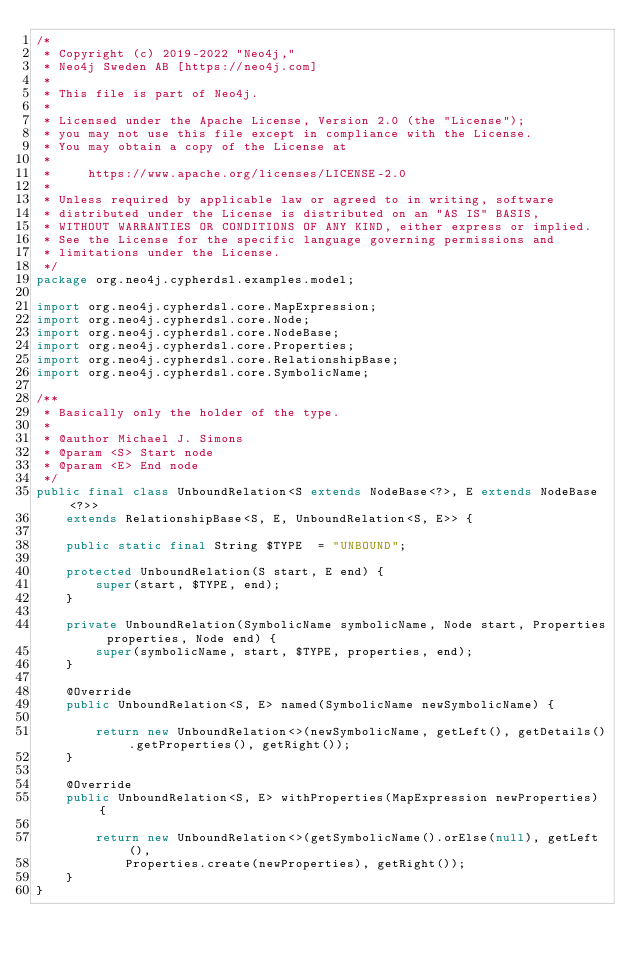Convert code to text. <code><loc_0><loc_0><loc_500><loc_500><_Java_>/*
 * Copyright (c) 2019-2022 "Neo4j,"
 * Neo4j Sweden AB [https://neo4j.com]
 *
 * This file is part of Neo4j.
 *
 * Licensed under the Apache License, Version 2.0 (the "License");
 * you may not use this file except in compliance with the License.
 * You may obtain a copy of the License at
 *
 *     https://www.apache.org/licenses/LICENSE-2.0
 *
 * Unless required by applicable law or agreed to in writing, software
 * distributed under the License is distributed on an "AS IS" BASIS,
 * WITHOUT WARRANTIES OR CONDITIONS OF ANY KIND, either express or implied.
 * See the License for the specific language governing permissions and
 * limitations under the License.
 */
package org.neo4j.cypherdsl.examples.model;

import org.neo4j.cypherdsl.core.MapExpression;
import org.neo4j.cypherdsl.core.Node;
import org.neo4j.cypherdsl.core.NodeBase;
import org.neo4j.cypherdsl.core.Properties;
import org.neo4j.cypherdsl.core.RelationshipBase;
import org.neo4j.cypherdsl.core.SymbolicName;

/**
 * Basically only the holder of the type.
 *
 * @author Michael J. Simons
 * @param <S> Start node
 * @param <E> End node
 */
public final class UnboundRelation<S extends NodeBase<?>, E extends NodeBase<?>>
	extends RelationshipBase<S, E, UnboundRelation<S, E>> {

	public static final String $TYPE  = "UNBOUND";

	protected UnboundRelation(S start, E end) {
		super(start, $TYPE, end);
	}

	private UnboundRelation(SymbolicName symbolicName, Node start, Properties properties, Node end) {
		super(symbolicName, start, $TYPE, properties, end);
	}

	@Override
	public UnboundRelation<S, E> named(SymbolicName newSymbolicName) {

		return new UnboundRelation<>(newSymbolicName, getLeft(), getDetails().getProperties(), getRight());
	}

	@Override
	public UnboundRelation<S, E> withProperties(MapExpression newProperties) {

		return new UnboundRelation<>(getSymbolicName().orElse(null), getLeft(),
			Properties.create(newProperties), getRight());
	}
}
</code> 